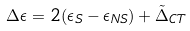Convert formula to latex. <formula><loc_0><loc_0><loc_500><loc_500>\Delta \epsilon = 2 ( \epsilon _ { S } - \epsilon _ { N S } ) + \tilde { \Delta } _ { C T }</formula> 